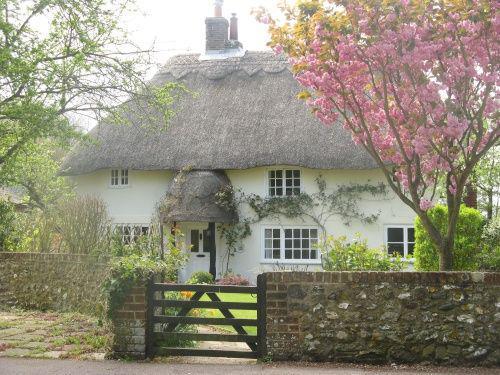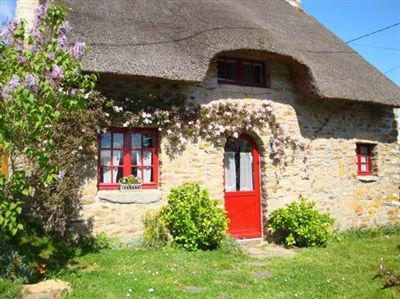The first image is the image on the left, the second image is the image on the right. For the images shown, is this caption "A house has a red door." true? Answer yes or no. Yes. 